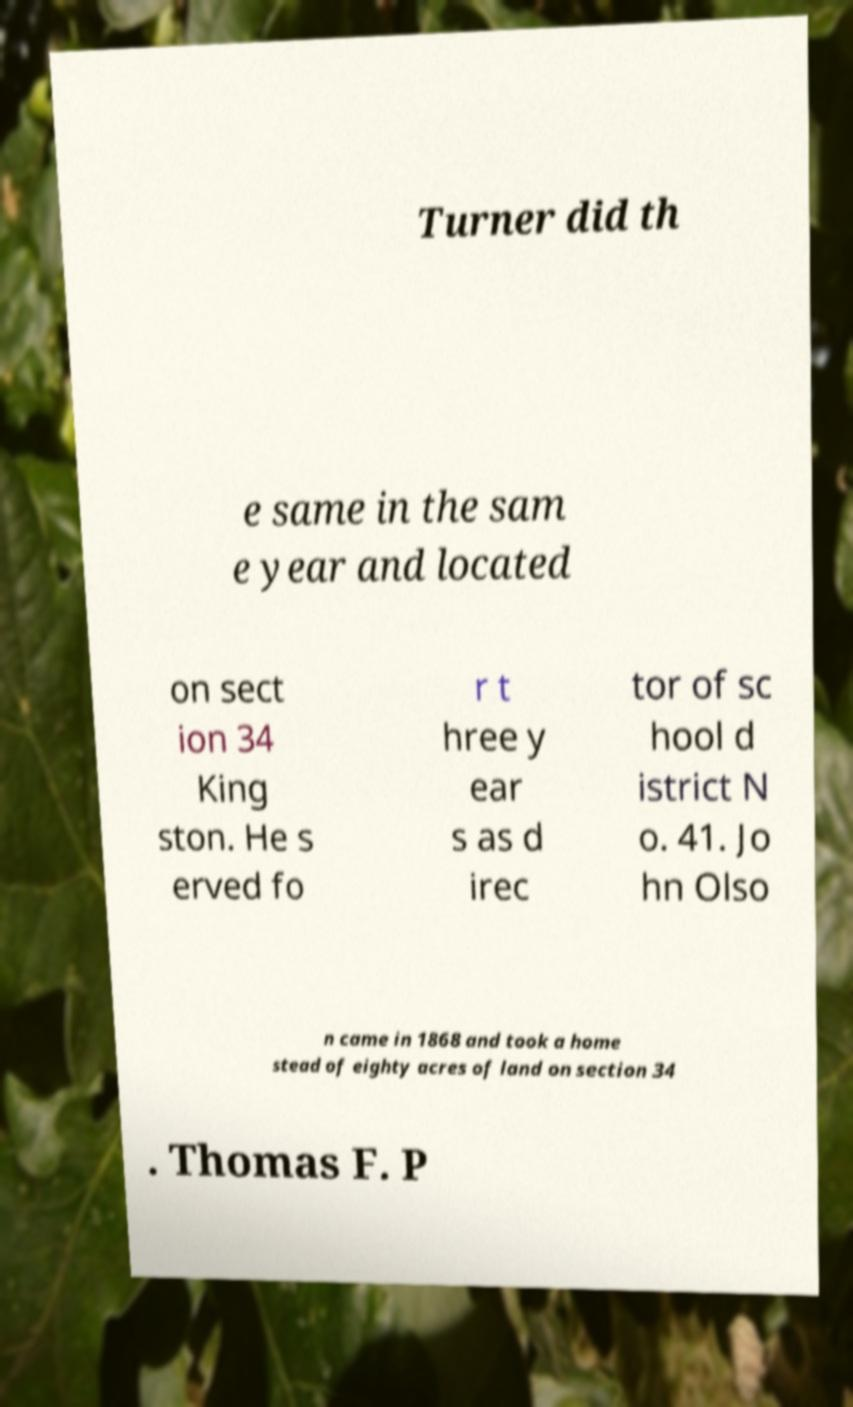Please identify and transcribe the text found in this image. Turner did th e same in the sam e year and located on sect ion 34 King ston. He s erved fo r t hree y ear s as d irec tor of sc hool d istrict N o. 41. Jo hn Olso n came in 1868 and took a home stead of eighty acres of land on section 34 . Thomas F. P 